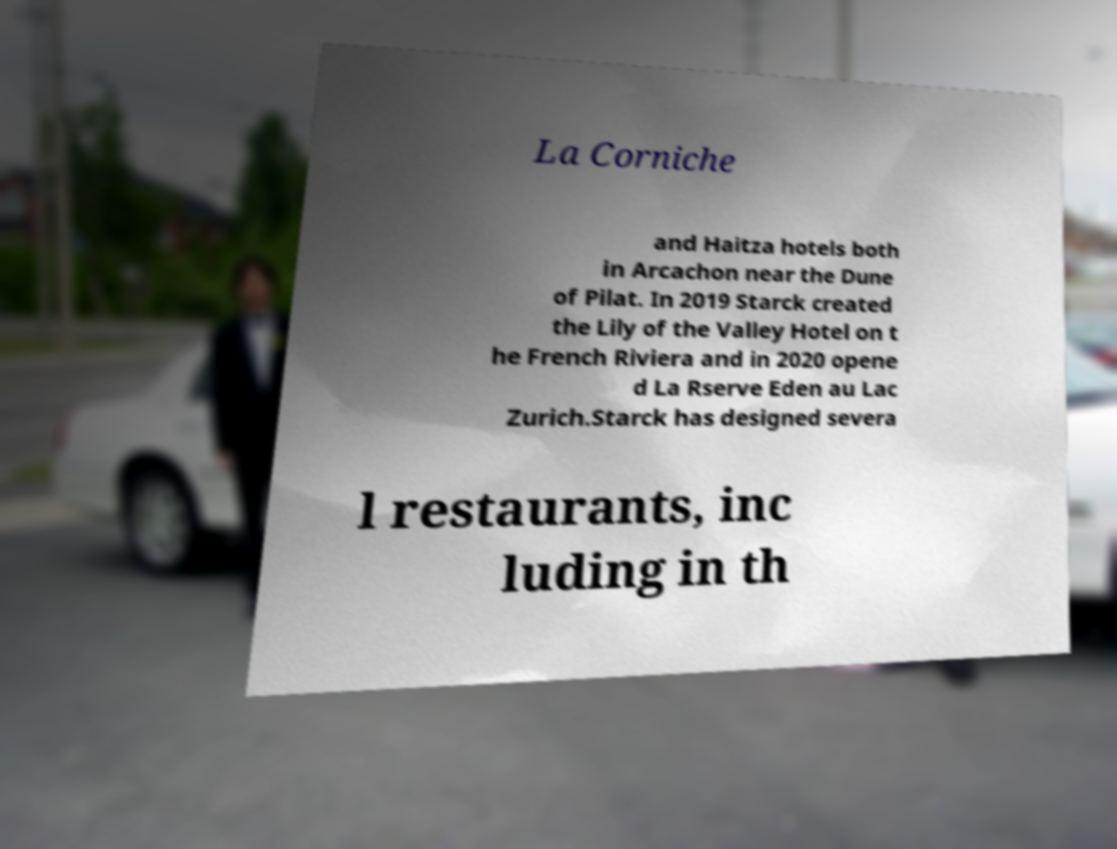Can you accurately transcribe the text from the provided image for me? La Corniche and Haitza hotels both in Arcachon near the Dune of Pilat. In 2019 Starck created the Lily of the Valley Hotel on t he French Riviera and in 2020 opene d La Rserve Eden au Lac Zurich.Starck has designed severa l restaurants, inc luding in th 